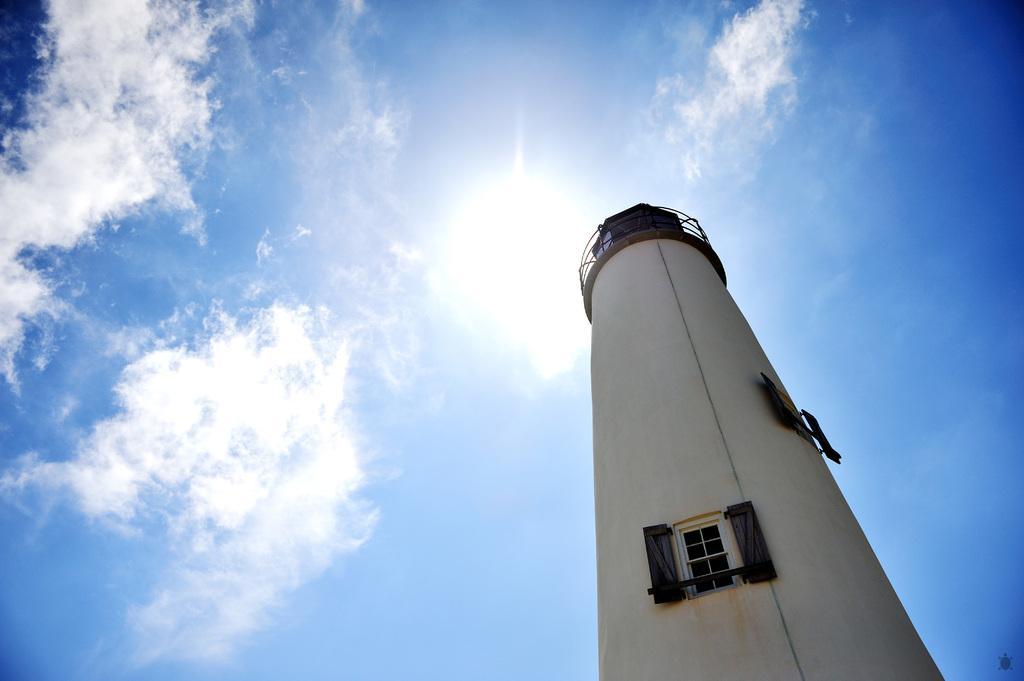How would you summarize this image in a sentence or two? In front of the picture, we see a tower in white color. We see the windows. In the background, we see the clouds, the sun and the sky, which is blue in color. 